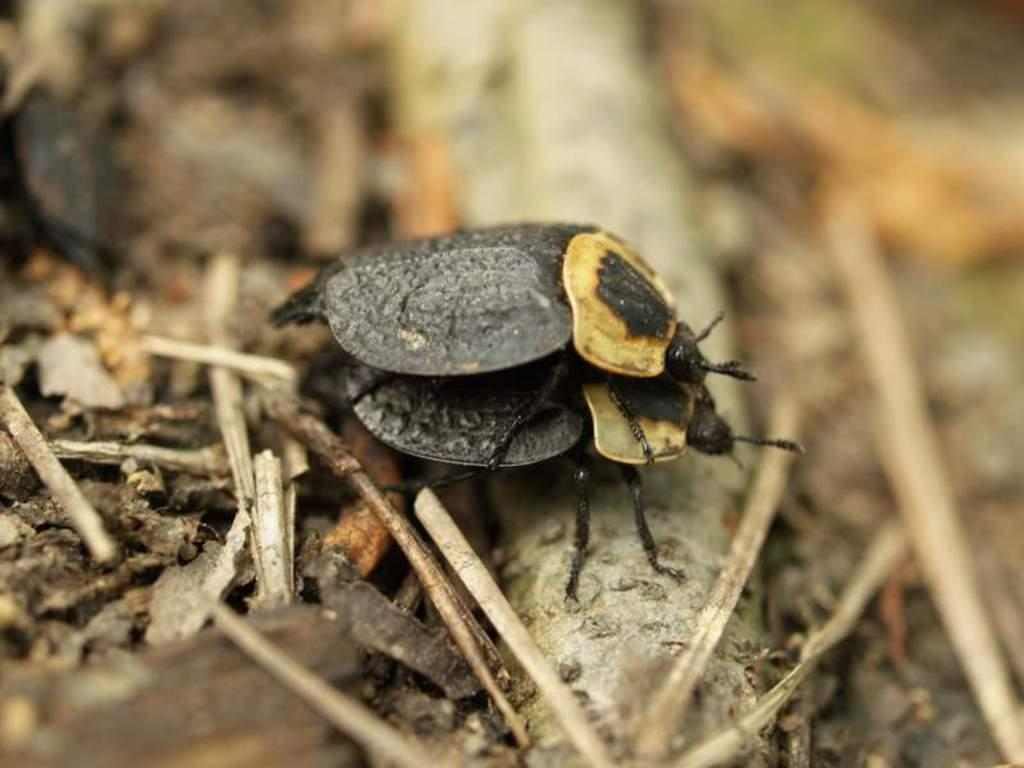What type of creature can be seen in the image? There is an insect in the image. Can you describe the background of the image? The background of the image is blurry. What is the average income of the insect in the image? There is no information about the income of the insect in the image, as insects do not have income. 